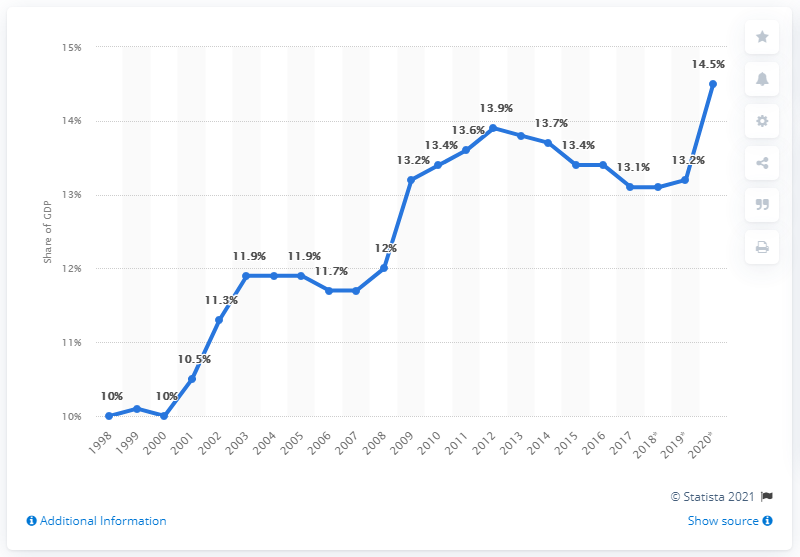List a handful of essential elements in this visual. In 2008, it was compulsory to pay a total mandatory excess before the basic health insurance would reimburse medical costs. In 2020, the total health expenditure in the Netherlands was 14.5 billion U.S. dollars. 